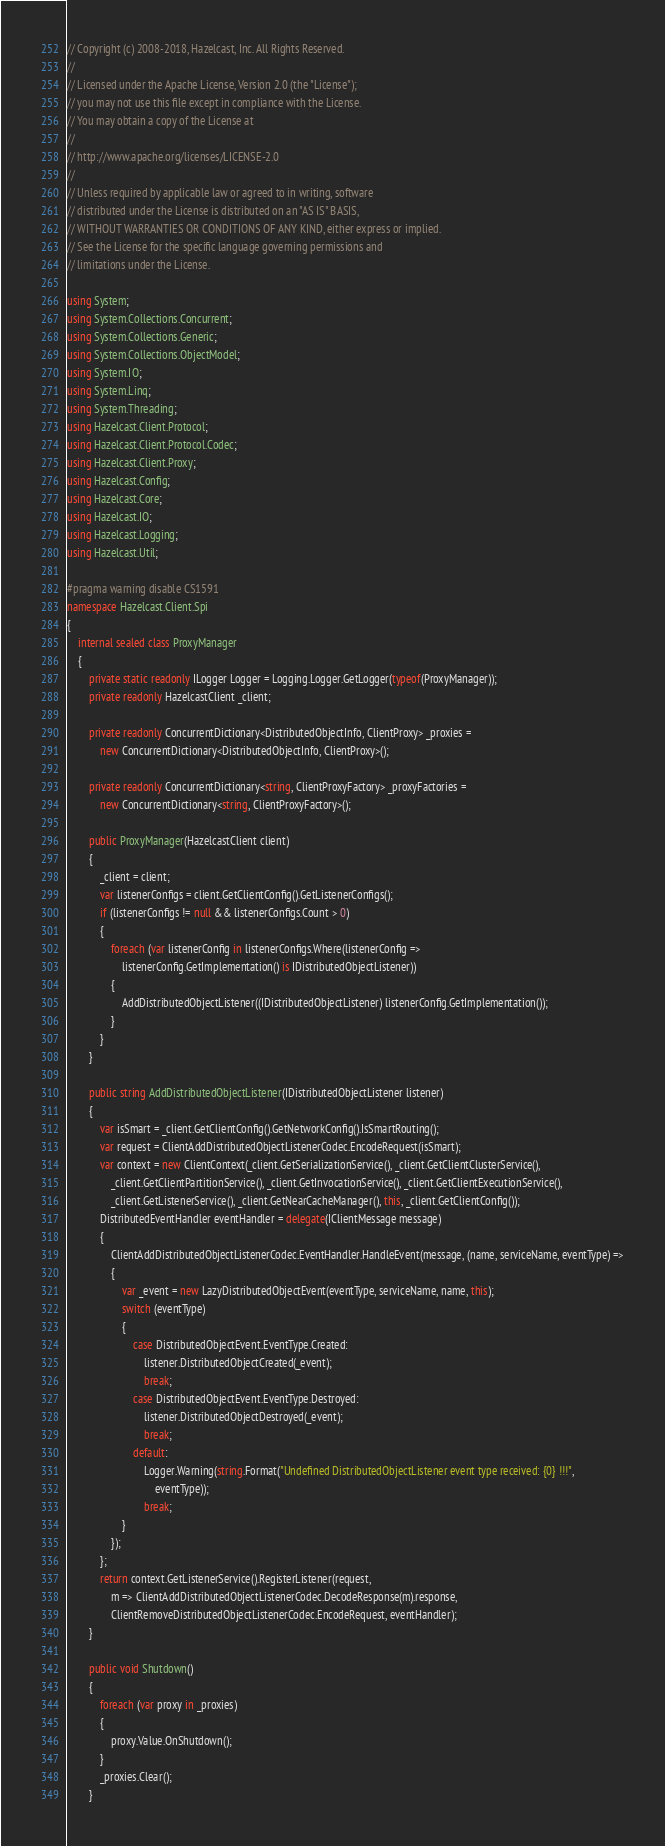Convert code to text. <code><loc_0><loc_0><loc_500><loc_500><_C#_>// Copyright (c) 2008-2018, Hazelcast, Inc. All Rights Reserved.
// 
// Licensed under the Apache License, Version 2.0 (the "License");
// you may not use this file except in compliance with the License.
// You may obtain a copy of the License at
// 
// http://www.apache.org/licenses/LICENSE-2.0
// 
// Unless required by applicable law or agreed to in writing, software
// distributed under the License is distributed on an "AS IS" BASIS,
// WITHOUT WARRANTIES OR CONDITIONS OF ANY KIND, either express or implied.
// See the License for the specific language governing permissions and
// limitations under the License.

using System;
using System.Collections.Concurrent;
using System.Collections.Generic;
using System.Collections.ObjectModel;
using System.IO;
using System.Linq;
using System.Threading;
using Hazelcast.Client.Protocol;
using Hazelcast.Client.Protocol.Codec;
using Hazelcast.Client.Proxy;
using Hazelcast.Config;
using Hazelcast.Core;
using Hazelcast.IO;
using Hazelcast.Logging;
using Hazelcast.Util;

#pragma warning disable CS1591
namespace Hazelcast.Client.Spi
{
    internal sealed class ProxyManager
    {
        private static readonly ILogger Logger = Logging.Logger.GetLogger(typeof(ProxyManager));
        private readonly HazelcastClient _client;

        private readonly ConcurrentDictionary<DistributedObjectInfo, ClientProxy> _proxies =
            new ConcurrentDictionary<DistributedObjectInfo, ClientProxy>();

        private readonly ConcurrentDictionary<string, ClientProxyFactory> _proxyFactories =
            new ConcurrentDictionary<string, ClientProxyFactory>();

        public ProxyManager(HazelcastClient client)
        {
            _client = client;
            var listenerConfigs = client.GetClientConfig().GetListenerConfigs();
            if (listenerConfigs != null && listenerConfigs.Count > 0)
            {
                foreach (var listenerConfig in listenerConfigs.Where(listenerConfig =>
                    listenerConfig.GetImplementation() is IDistributedObjectListener))
                {
                    AddDistributedObjectListener((IDistributedObjectListener) listenerConfig.GetImplementation());
                }
            }
        }

        public string AddDistributedObjectListener(IDistributedObjectListener listener)
        {
            var isSmart = _client.GetClientConfig().GetNetworkConfig().IsSmartRouting();
            var request = ClientAddDistributedObjectListenerCodec.EncodeRequest(isSmart);
            var context = new ClientContext(_client.GetSerializationService(), _client.GetClientClusterService(),
                _client.GetClientPartitionService(), _client.GetInvocationService(), _client.GetClientExecutionService(),
                _client.GetListenerService(), _client.GetNearCacheManager(), this, _client.GetClientConfig());
            DistributedEventHandler eventHandler = delegate(IClientMessage message)
            {
                ClientAddDistributedObjectListenerCodec.EventHandler.HandleEvent(message, (name, serviceName, eventType) =>
                {
                    var _event = new LazyDistributedObjectEvent(eventType, serviceName, name, this);
                    switch (eventType)
                    {
                        case DistributedObjectEvent.EventType.Created:
                            listener.DistributedObjectCreated(_event);
                            break;
                        case DistributedObjectEvent.EventType.Destroyed:
                            listener.DistributedObjectDestroyed(_event);
                            break;
                        default:
                            Logger.Warning(string.Format("Undefined DistributedObjectListener event type received: {0} !!!",
                                eventType));
                            break;
                    }
                });
            };
            return context.GetListenerService().RegisterListener(request,
                m => ClientAddDistributedObjectListenerCodec.DecodeResponse(m).response,
                ClientRemoveDistributedObjectListenerCodec.EncodeRequest, eventHandler);
        }

        public void Shutdown()
        {
            foreach (var proxy in _proxies)
            {
                proxy.Value.OnShutdown();
            }
            _proxies.Clear();
        }
</code> 